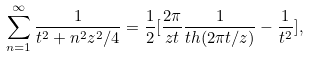<formula> <loc_0><loc_0><loc_500><loc_500>\sum _ { n = 1 } ^ { \infty } \frac { 1 } { t ^ { 2 } + n ^ { 2 } z ^ { 2 } / 4 } = \frac { 1 } { 2 } [ \frac { 2 \pi } { z t } \frac { 1 } { t h ( 2 \pi t / z ) } - \frac { 1 } { t ^ { 2 } } ] ,</formula> 